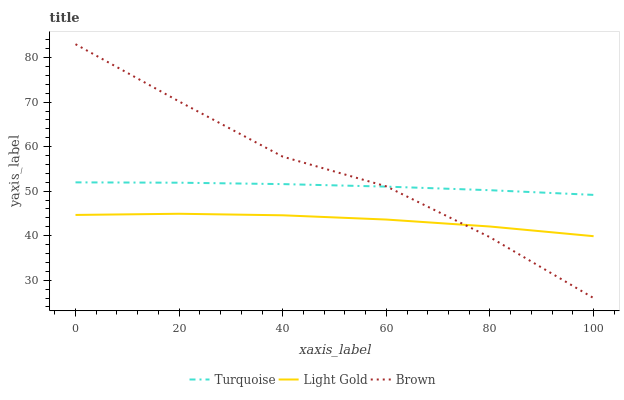Does Light Gold have the minimum area under the curve?
Answer yes or no. Yes. Does Brown have the maximum area under the curve?
Answer yes or no. Yes. Does Turquoise have the minimum area under the curve?
Answer yes or no. No. Does Turquoise have the maximum area under the curve?
Answer yes or no. No. Is Turquoise the smoothest?
Answer yes or no. Yes. Is Brown the roughest?
Answer yes or no. Yes. Is Light Gold the smoothest?
Answer yes or no. No. Is Light Gold the roughest?
Answer yes or no. No. Does Brown have the lowest value?
Answer yes or no. Yes. Does Light Gold have the lowest value?
Answer yes or no. No. Does Brown have the highest value?
Answer yes or no. Yes. Does Turquoise have the highest value?
Answer yes or no. No. Is Light Gold less than Turquoise?
Answer yes or no. Yes. Is Turquoise greater than Light Gold?
Answer yes or no. Yes. Does Brown intersect Light Gold?
Answer yes or no. Yes. Is Brown less than Light Gold?
Answer yes or no. No. Is Brown greater than Light Gold?
Answer yes or no. No. Does Light Gold intersect Turquoise?
Answer yes or no. No. 